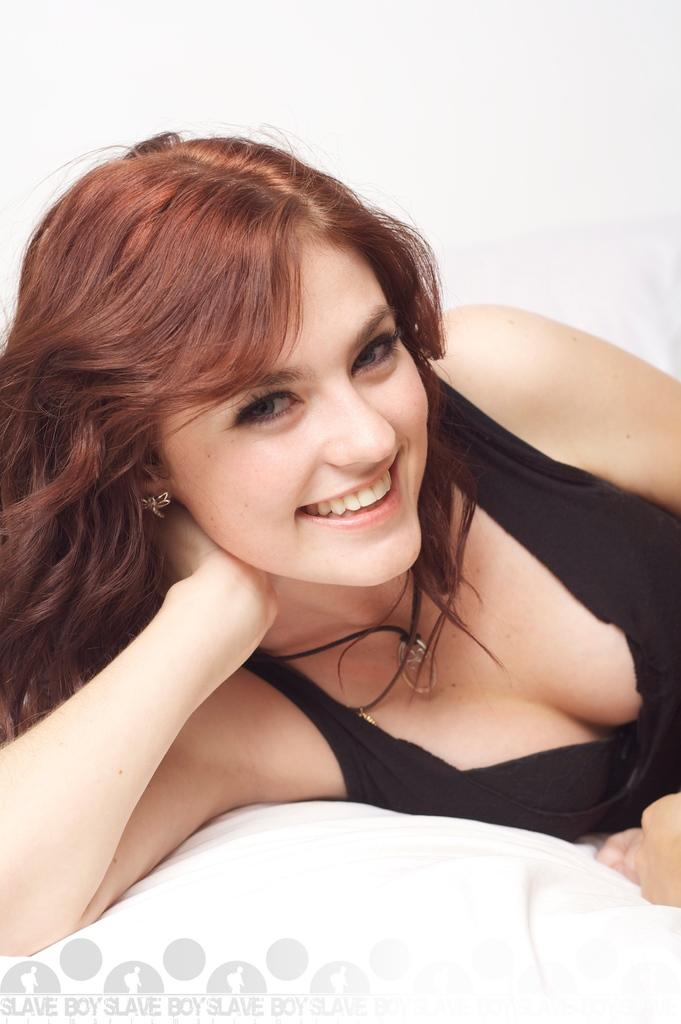What is the main subject of the image? The main subject of the image is a lady person. What is the lady person wearing in the image? The lady person is wearing a black dress. What is the lady person's position in the image? The lady person is lying on a bed. What type of chain can be seen hanging from the ceiling above the lady person in the image? There is no chain present in the image. What type of meat is being prepared on the bed next to the lady person in the image? There is no meat or any food preparation visible in the image. What type of whip is being used on the lady person in the image? There is no whip or any indication of physical punishment in the image. 